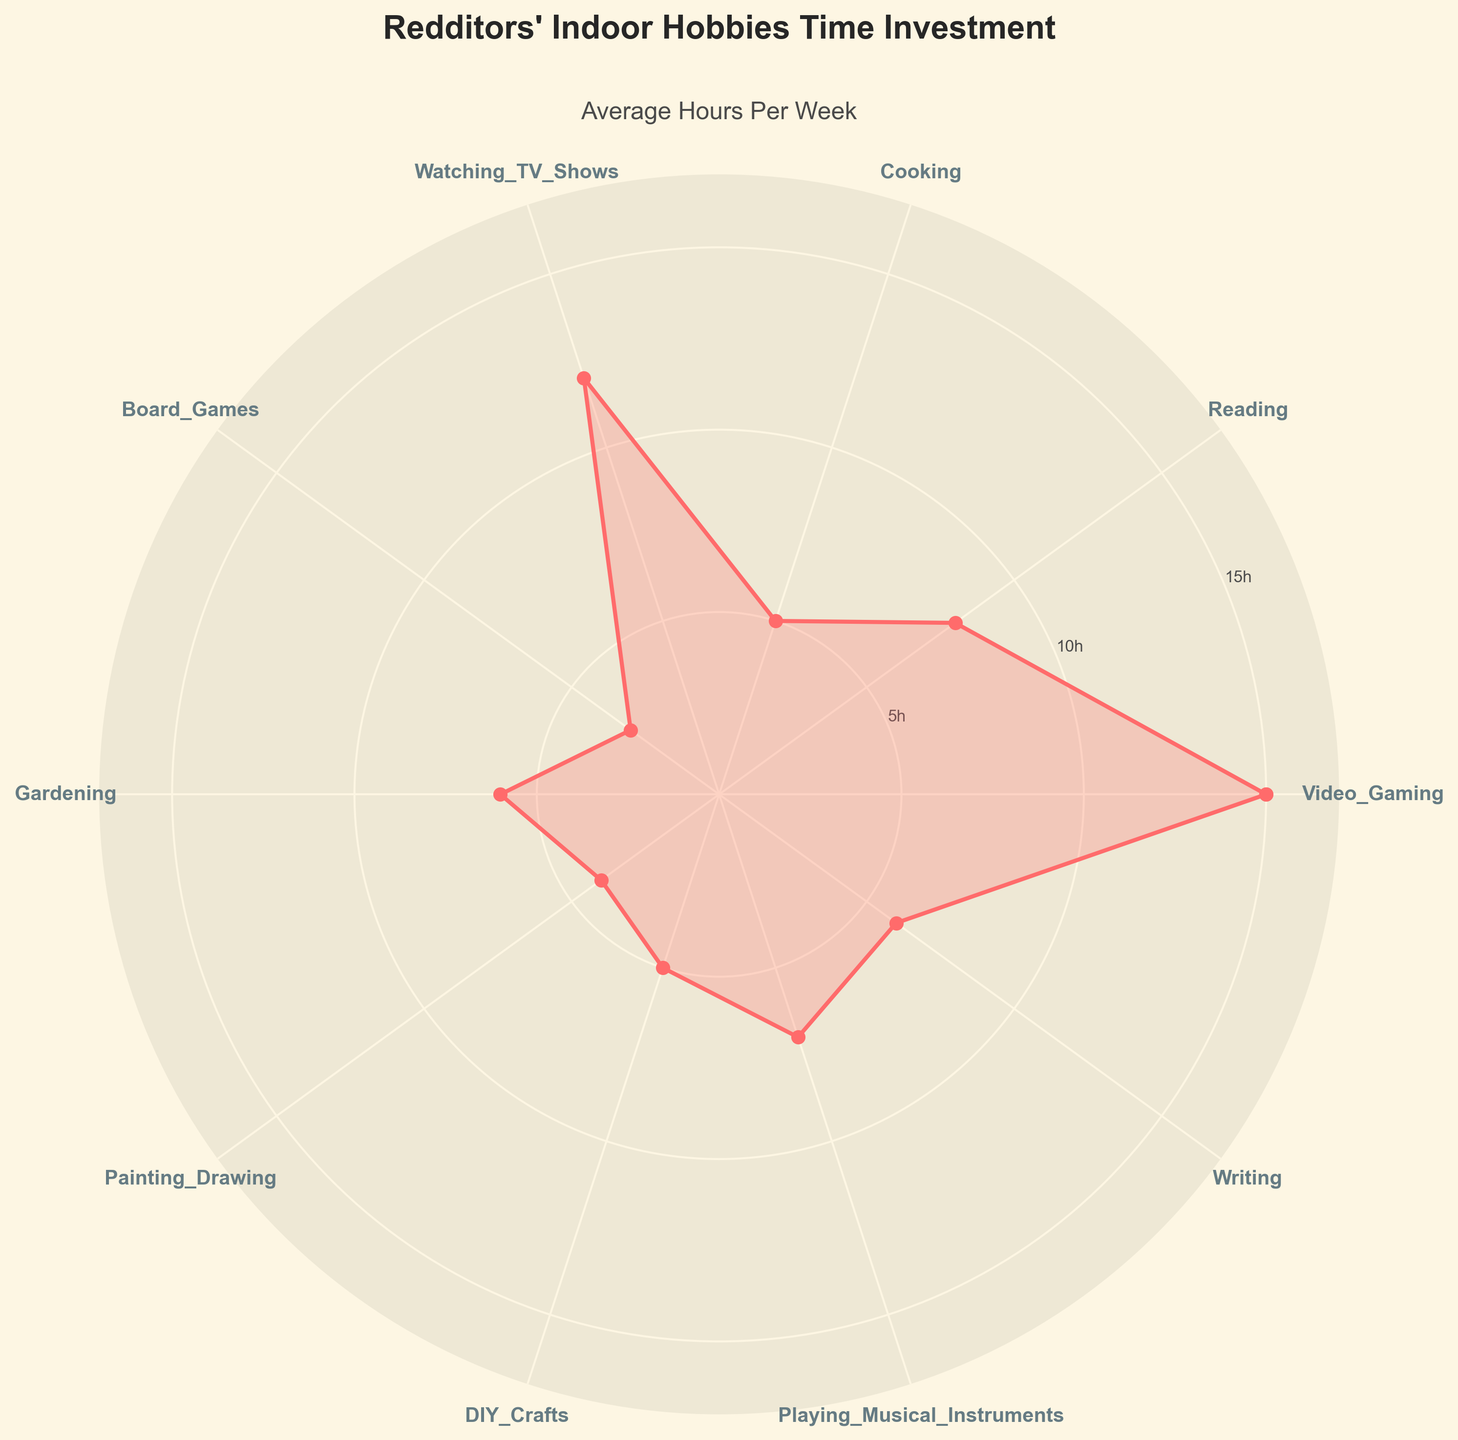What's the title of the chart? The title is located at the top of the chart and is usually styled in a larger, bold font.
Answer: Redditors' Indoor Hobbies Time Investment How many hobbies are represented on the chart? Count the number of labels around the outer edge of the polar chart.
Answer: 10 Which hobby has the highest time investment per week? Look for the hobby where the point is farthest from the center of the chart. This corresponds to the highest value on the radial axis.
Answer: Video_Gaming What is the average time investment per week for Reading and Cooking combined? Reading has 8 hours/week and Cooking has 5 hours/week. Add these two values and then divide by 2 to get the average.
Answer: (8 + 5) / 2 = 6.5 hours/week Which two hobbies have the closest time investments? Look for the hobbies whose points are closest to each other on the radial axis.
Answer: Writing and Gardening What is the difference in time investment between Video_Gaming and Board_Games? Subtract the time investment of Board_Games from that of Video_Gaming.
Answer: 15 - 3 = 12 hours/week Which hobbies have a time investment of 5 hours per week? Identify hobbies where the data point intersects the radial grid line labeled '5h'.
Answer: Cooking and DIY_Crafts Is Playing_Musical_Instruments invested in more or less time than Watching_TV_Shows? Compare the radial lengths of Playing_Musical_Instruments and Watching_TV_Shows.
Answer: Less Does the plot use the same color to fill in the area under the data curve and plot the data points? Observe whether the fill color and the color of the line/points are the same.
Answer: Yes What's the median time investment among the listed hobbies? List the time investments in ascending order: 3, 4, 5, 5, 6, 6, 7, 8, 12, 15. The median is the middle value or the average of the two middle values if the count is even.
Answer: (6 + 6) / 2 = 6 hours/week 